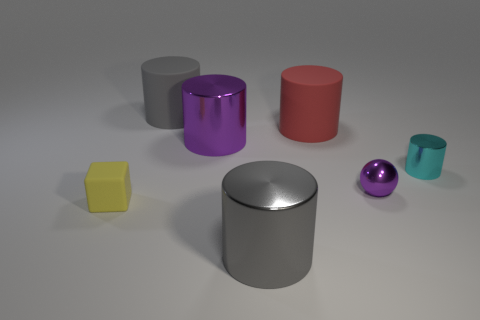What number of cyan metallic things have the same size as the purple shiny cylinder?
Your response must be concise. 0. There is a matte object that is to the left of the rubber cylinder that is left of the big purple metal cylinder; what is its shape?
Your answer should be very brief. Cube. Is the number of metal balls less than the number of blue metal cylinders?
Provide a succinct answer. No. The rubber cylinder right of the gray metallic object is what color?
Your response must be concise. Red. What is the material of the thing that is both in front of the purple sphere and right of the cube?
Provide a short and direct response. Metal. The big red object that is the same material as the small block is what shape?
Ensure brevity in your answer.  Cylinder. How many small blocks are behind the big metal object behind the tiny cube?
Keep it short and to the point. 0. How many large gray cylinders are in front of the big red matte thing and behind the small yellow matte object?
Provide a short and direct response. 0. How many other objects are there of the same material as the big red cylinder?
Make the answer very short. 2. The large shiny cylinder in front of the purple metal sphere that is on the right side of the yellow rubber object is what color?
Ensure brevity in your answer.  Gray. 